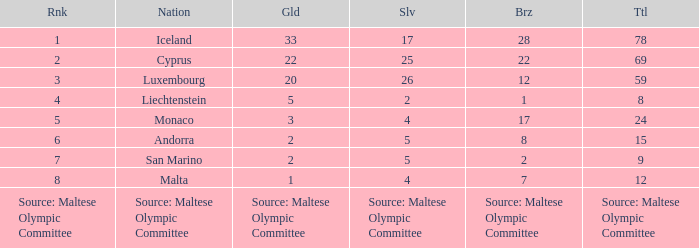What is the position of the country with a bronze medal according to the maltese olympic committee source? Source: Maltese Olympic Committee. 